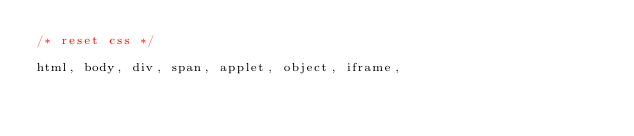Convert code to text. <code><loc_0><loc_0><loc_500><loc_500><_CSS_>/* reset css */

html, body, div, span, applet, object, iframe,</code> 